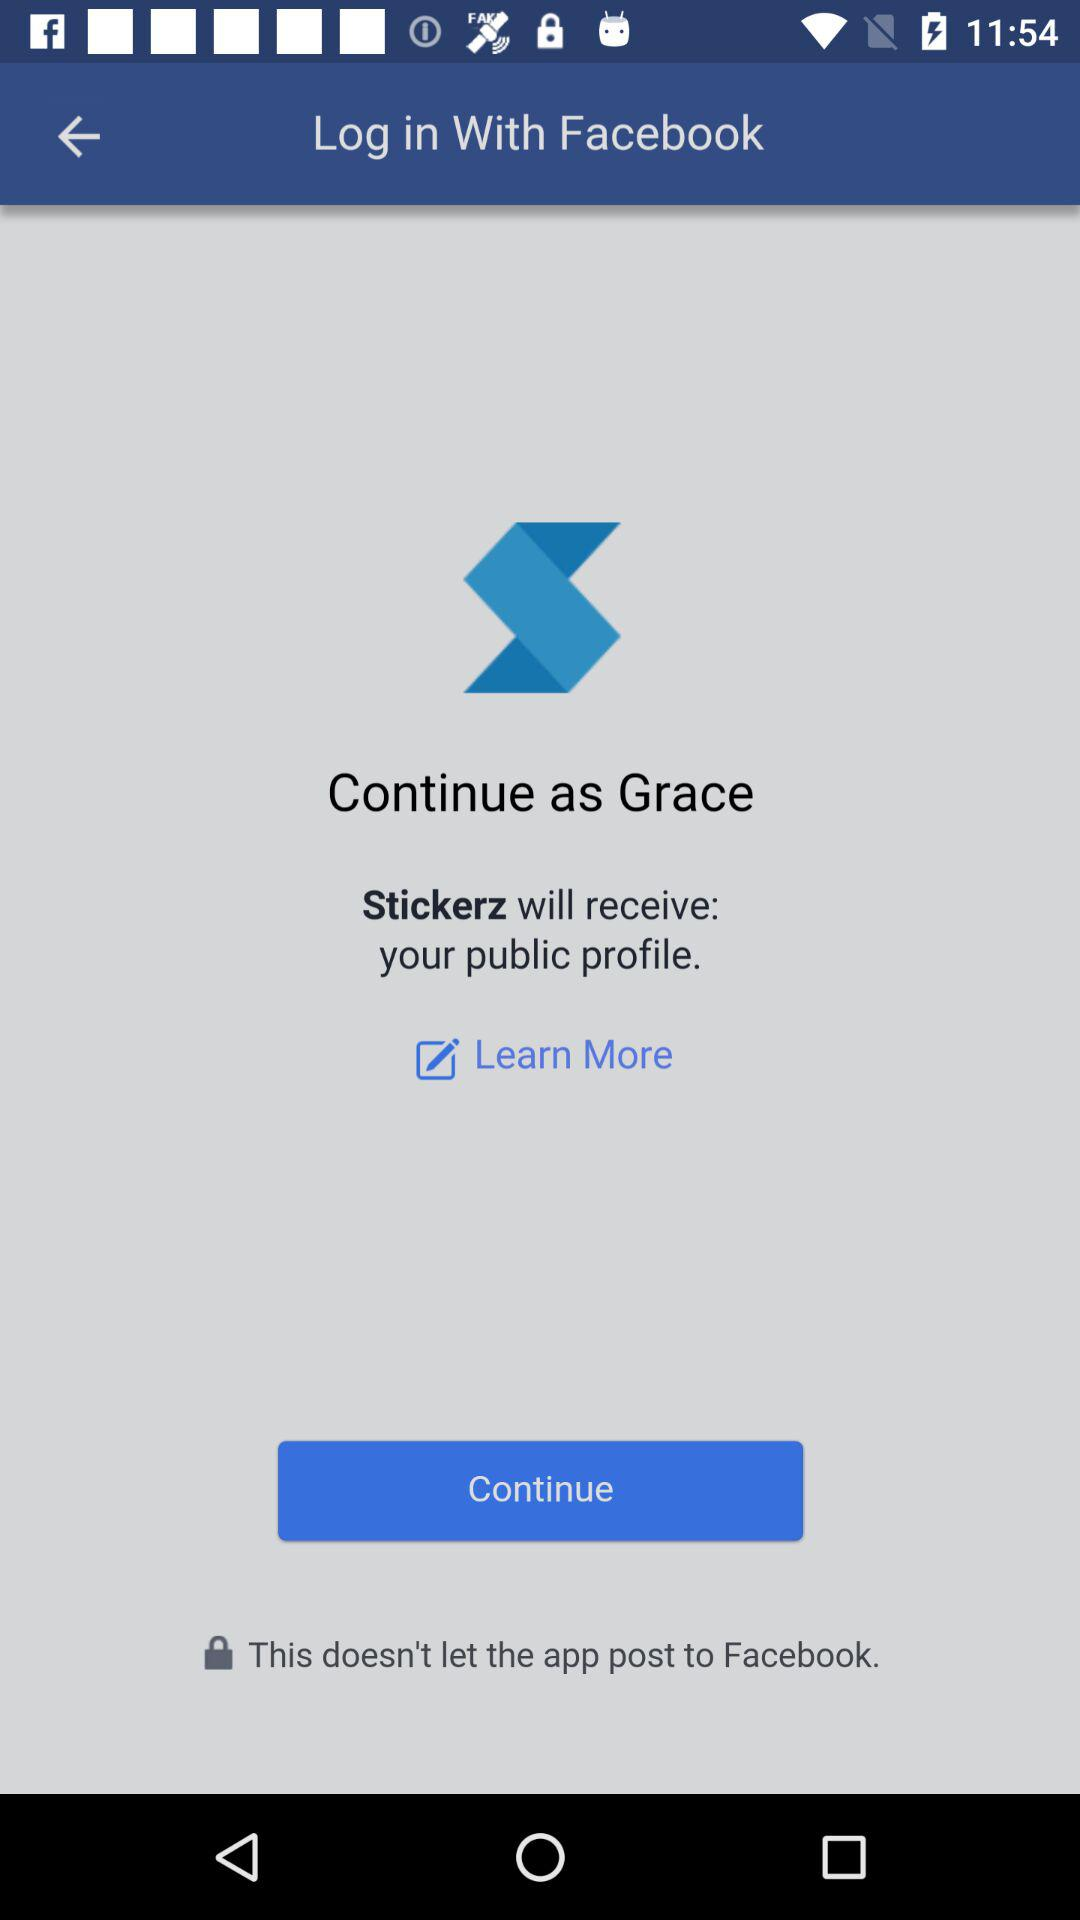What application can we log in with? You can log in with "Facebook". 